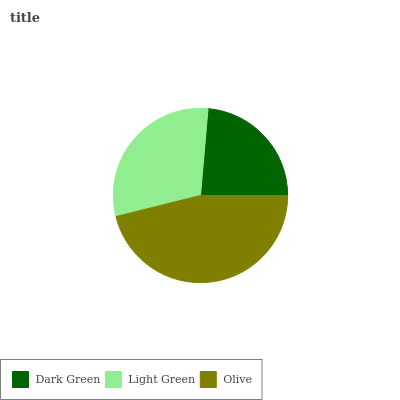Is Dark Green the minimum?
Answer yes or no. Yes. Is Olive the maximum?
Answer yes or no. Yes. Is Light Green the minimum?
Answer yes or no. No. Is Light Green the maximum?
Answer yes or no. No. Is Light Green greater than Dark Green?
Answer yes or no. Yes. Is Dark Green less than Light Green?
Answer yes or no. Yes. Is Dark Green greater than Light Green?
Answer yes or no. No. Is Light Green less than Dark Green?
Answer yes or no. No. Is Light Green the high median?
Answer yes or no. Yes. Is Light Green the low median?
Answer yes or no. Yes. Is Olive the high median?
Answer yes or no. No. Is Olive the low median?
Answer yes or no. No. 